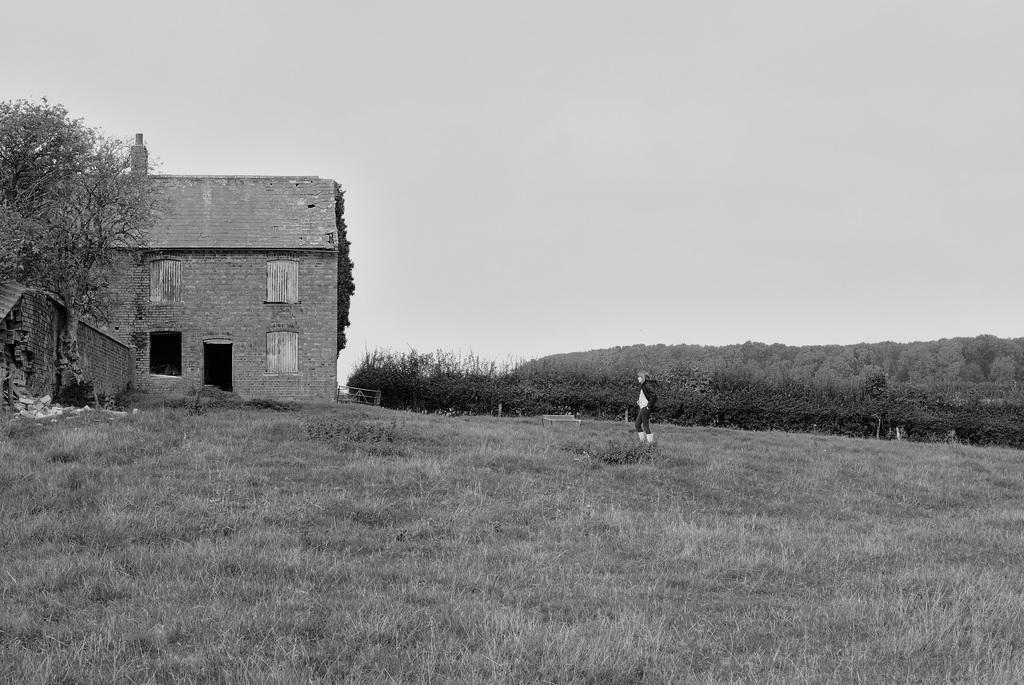Could you give a brief overview of what you see in this image? It looks like a black and white picture. We can see a person is standing on the grass. On the left side of the person there is a house and a wall. Behind the person there are trees and the sky. 